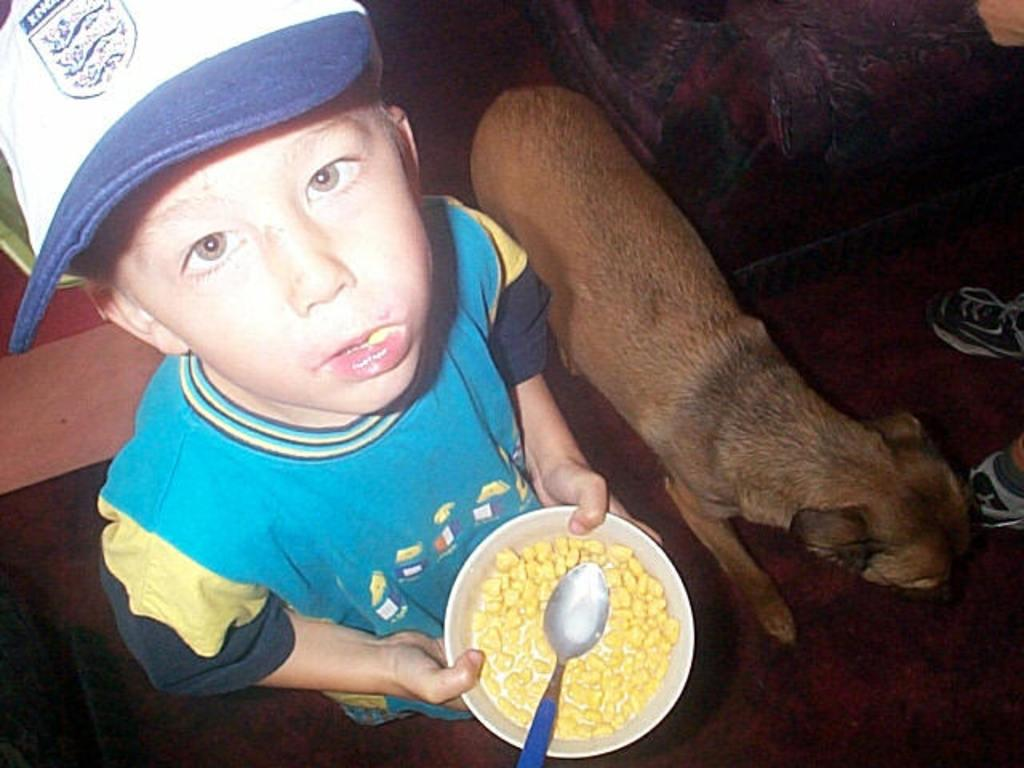What animal is present in the image? There is a dog in the image. Who is the other person in the image? There is a boy in the image. What is the boy wearing on his head? The boy is wearing a cap. What color is the boy's t-shirt? The boy is wearing a sky blue color t-shirt. What is the boy holding in the image? The boy is holding a bowl. What is inside the bowl that the boy is holding? There is a dish in the bowl. What type of wire is being used to heat the dish in the image? There is no wire or heating element present in the image; the dish is simply inside the bowl. 